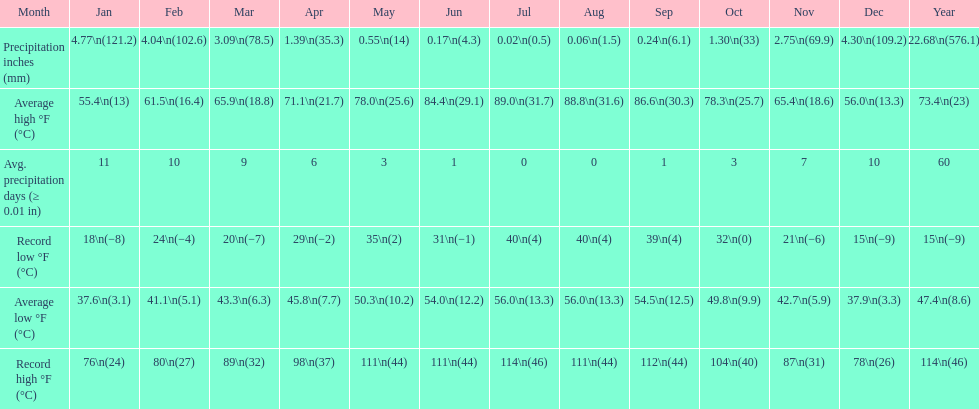In which month did the average high temperature reach 8 July. 